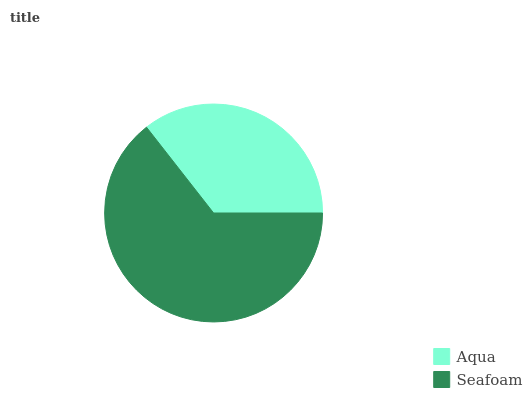Is Aqua the minimum?
Answer yes or no. Yes. Is Seafoam the maximum?
Answer yes or no. Yes. Is Seafoam the minimum?
Answer yes or no. No. Is Seafoam greater than Aqua?
Answer yes or no. Yes. Is Aqua less than Seafoam?
Answer yes or no. Yes. Is Aqua greater than Seafoam?
Answer yes or no. No. Is Seafoam less than Aqua?
Answer yes or no. No. Is Seafoam the high median?
Answer yes or no. Yes. Is Aqua the low median?
Answer yes or no. Yes. Is Aqua the high median?
Answer yes or no. No. Is Seafoam the low median?
Answer yes or no. No. 